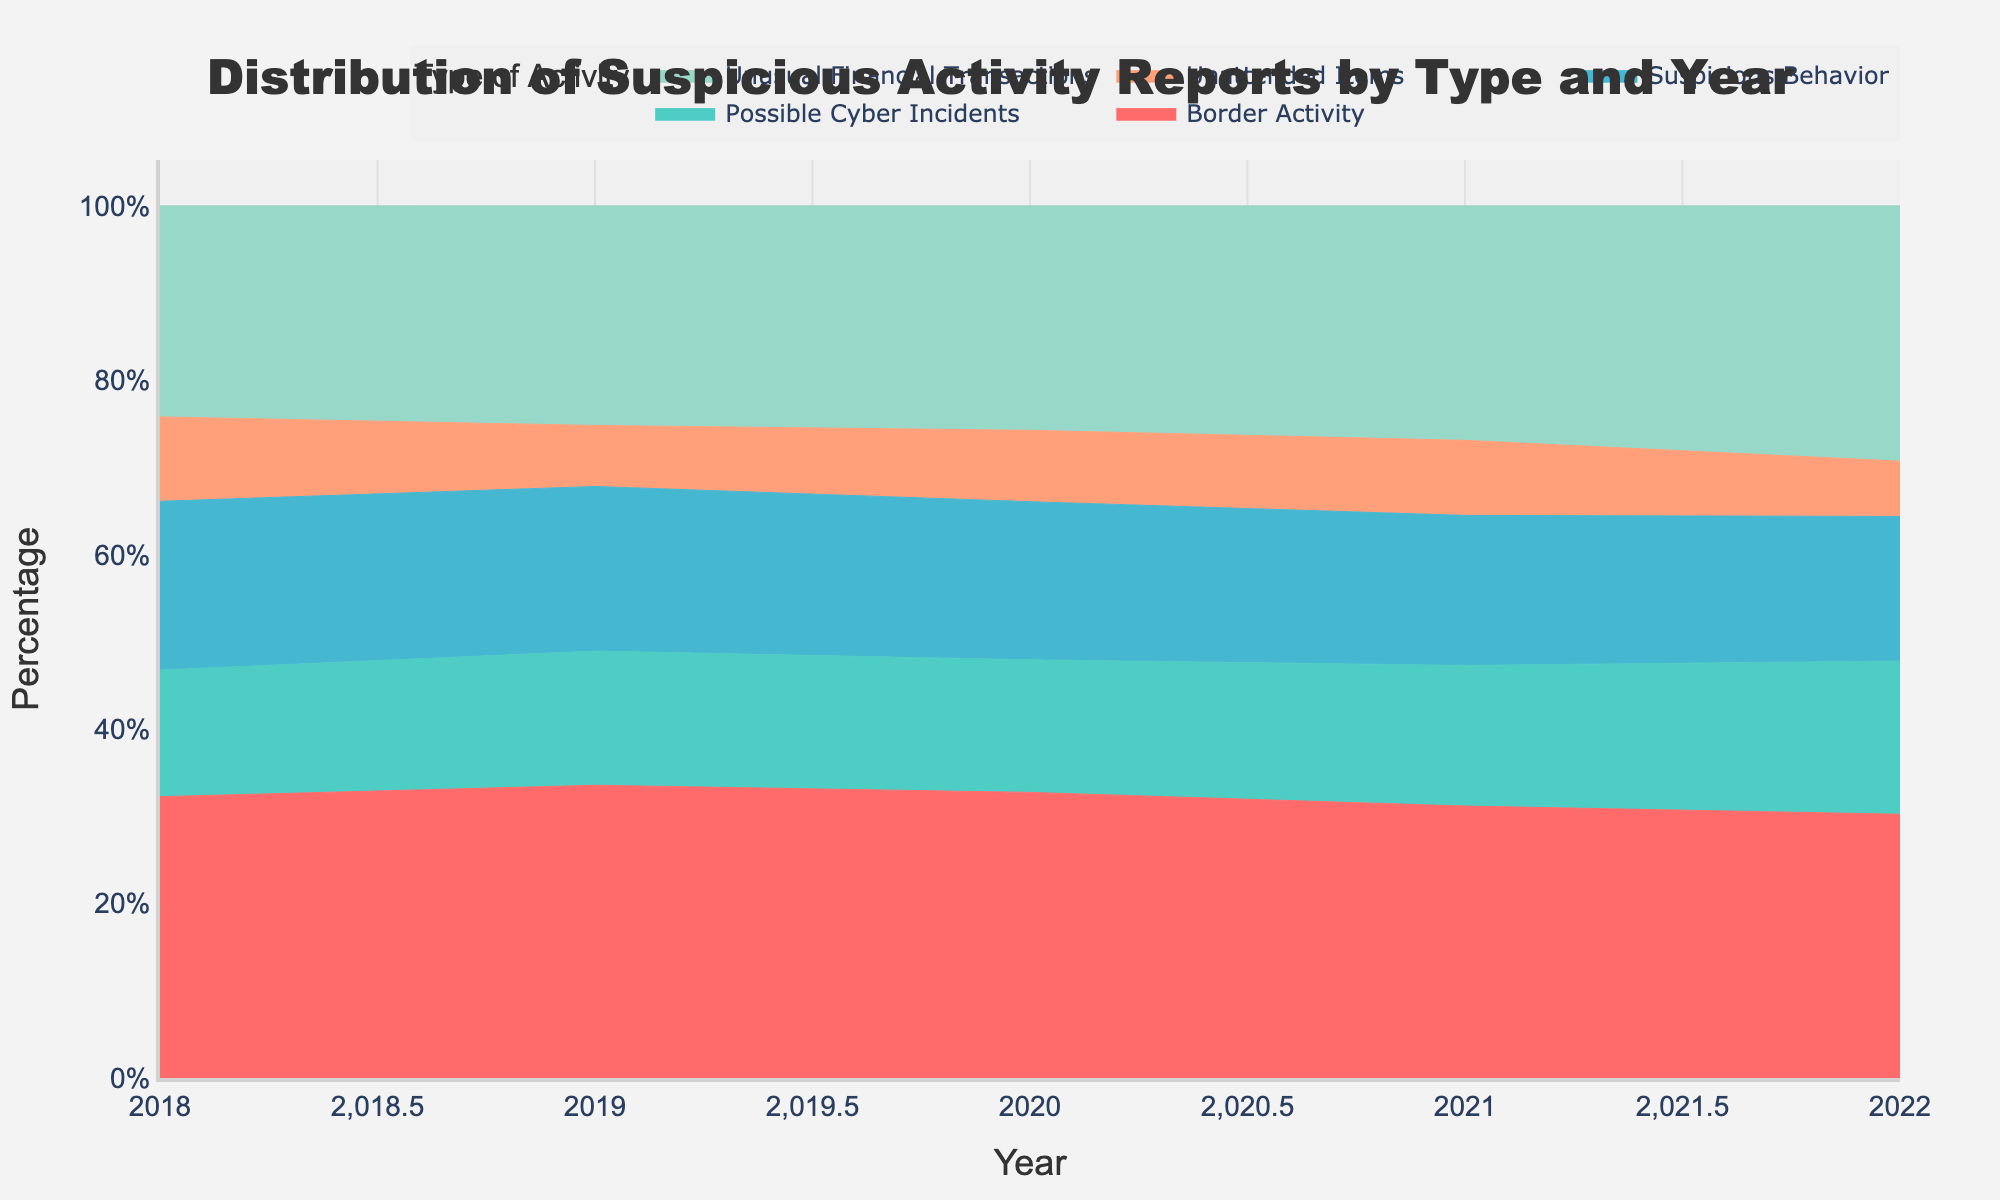What's the title of the figure? The title is displayed at the top-center of the figure in large font. It reads "Distribution of Suspicious Activity Reports by Type and Year"
Answer: Distribution of Suspicious Activity Reports by Type and Year How many types of suspicious activity are tracked in the figure? The legend shows five different colors with labels that represent the five types of suspicious activities tracked: Unusual Financial Transactions, Suspicious Behavior, Possible Cyber Incidents, Unattended Items, and Border Activity
Answer: Five Which type of activity had the highest count in 2022? From the figure, the section with the largest area (height) for 2022 belongs to "Border Activity," indicating it had the highest count
Answer: Border Activity How did the count of "Unusual Financial Transactions" change from 2019 to 2020? First, identify the areas for "Unusual Financial Transactions" in 2019 and 2020. The size was smaller in 2019 compared to 2020, indicating an increase. Comparing numbers, it increased from 180 to 220
Answer: Increased by 40 What was the general trend for "Possible Cyber Incidents" between 2018 and 2022? Observing the "Possible Cyber Incidents" area across years, it starts smaller in 2018 and gradually increases, peaking in 2022. This indicates an overall increasing trend
Answer: Increasing trend In which year did "Suspicious Behavior" have the highest count? By observing the highest peak in the area corresponding to "Suspicious Behavior," it is seen in 2022
Answer: 2022 Compare the count changes between "Unattended Items" and "Border Activity" from 2021 to 2022. Which one had a larger change? Checking both areas, "Unattended Items" decreased from 80 to 65 (15 less), while "Border Activity" increased from 290 to 310 (20 more). Hence, "Border Activity" had a larger change
Answer: Border Activity What's the sum of counts for all types of activity in 2020? Add the values for each type of activity in 2020: 220 (Unusual Financial Transactions) + 155 (Suspicious Behavior) + 130 (Possible Cyber Incidents) + 70 (Unattended Items) + 280 (Border Activity) = 855
Answer: 855 Which type of suspicious activity had the largest proportional increase from 2018 to 2022? Comparing the proportional changes from 2018 to 2022, "Possible Cyber Incidents" increased from 90 to 180, which is a 100% increase, the largest relative change among all types
Answer: Possible Cyber Incidents For each year, which type of activity accounts for the smallest percentage of total suspicious activities? By visually inspecting the stacked areas each year to find the smallest segment: 2018 - Unattended Items, 2019 - Unattended Items, 2020 - Unattended Items, 2021 - Unattended Items, 2022 - Unattended Items
Answer: Unattended Items 